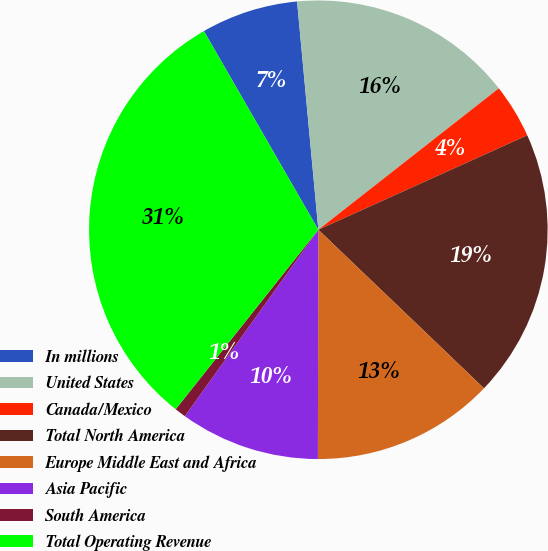Convert chart. <chart><loc_0><loc_0><loc_500><loc_500><pie_chart><fcel>In millions<fcel>United States<fcel>Canada/Mexico<fcel>Total North America<fcel>Europe Middle East and Africa<fcel>Asia Pacific<fcel>South America<fcel>Total Operating Revenue<nl><fcel>6.84%<fcel>15.9%<fcel>3.82%<fcel>18.91%<fcel>12.88%<fcel>9.86%<fcel>0.8%<fcel>30.99%<nl></chart> 